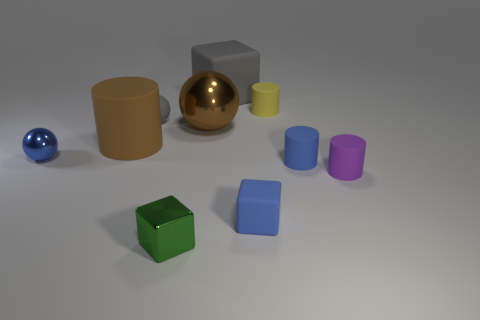Subtract all spheres. How many objects are left? 7 Subtract all small green matte spheres. Subtract all brown shiny spheres. How many objects are left? 9 Add 8 tiny rubber balls. How many tiny rubber balls are left? 9 Add 6 tiny red matte objects. How many tiny red matte objects exist? 6 Subtract 0 red cylinders. How many objects are left? 10 